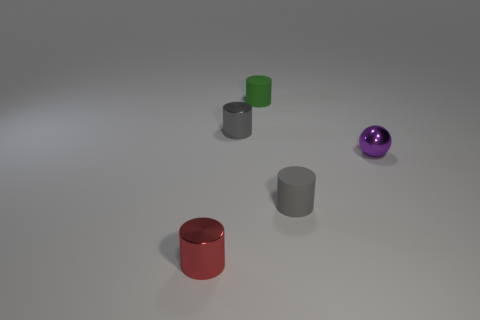These objects appear to be part of a setup; what could be the purpose of arranging them this way? This arrangement of objects looks like it could be used for a variety of purposes, such as a visual experiment in a physics study about shapes and materials, a demonstration of rendering techniques in 3D modeling software, or simply as an artistic composition to explore the interplay of colors and forms. 